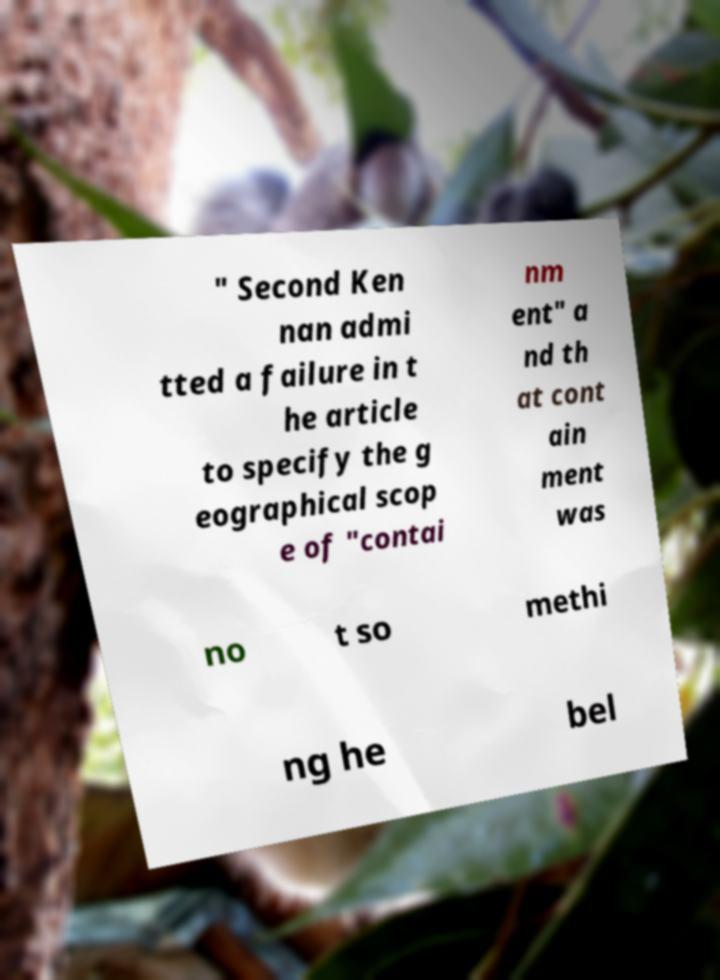Could you extract and type out the text from this image? " Second Ken nan admi tted a failure in t he article to specify the g eographical scop e of "contai nm ent" a nd th at cont ain ment was no t so methi ng he bel 